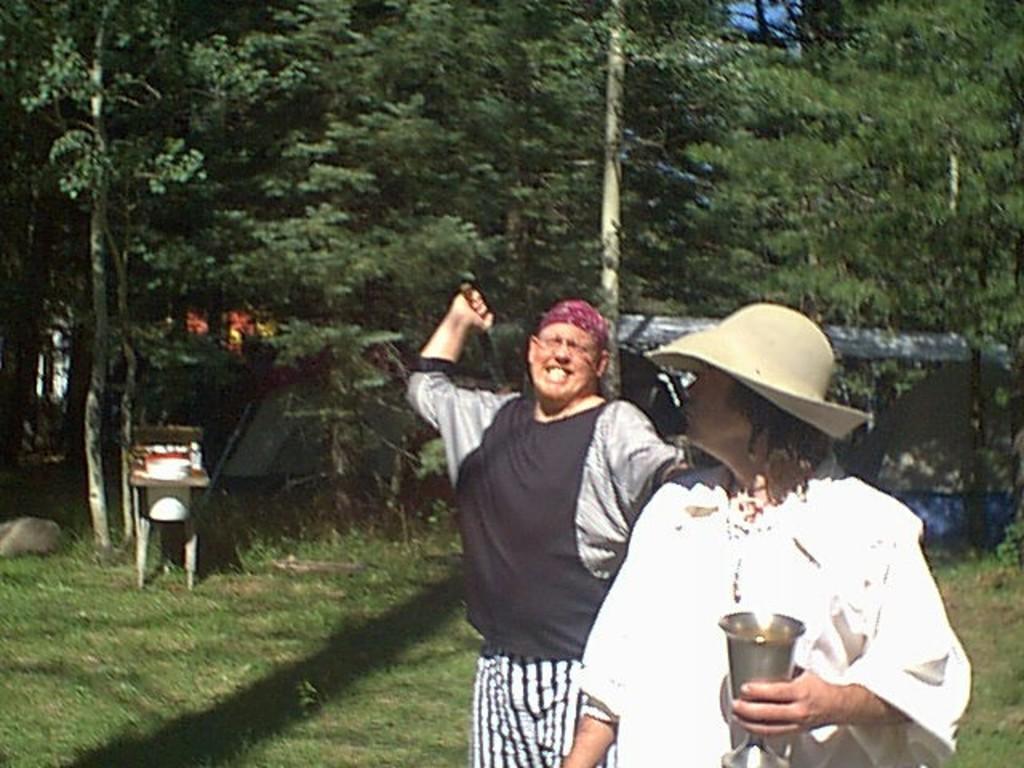Describe this image in one or two sentences. Here on the right side we can see a man standing and holding a glass in the hand and there is a hat on the head and behind the person we can see a man holding an object in his hand and in the background we can see trees,grass an object and a tent and this is a sky. 